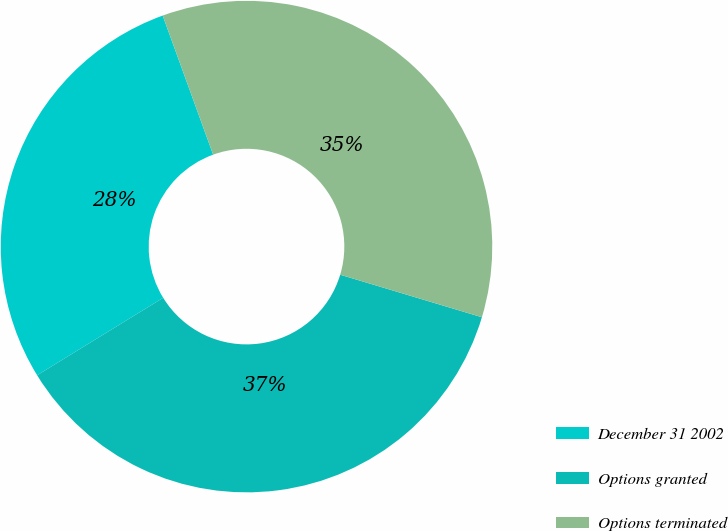<chart> <loc_0><loc_0><loc_500><loc_500><pie_chart><fcel>December 31 2002<fcel>Options granted<fcel>Options terminated<nl><fcel>28.23%<fcel>36.59%<fcel>35.18%<nl></chart> 